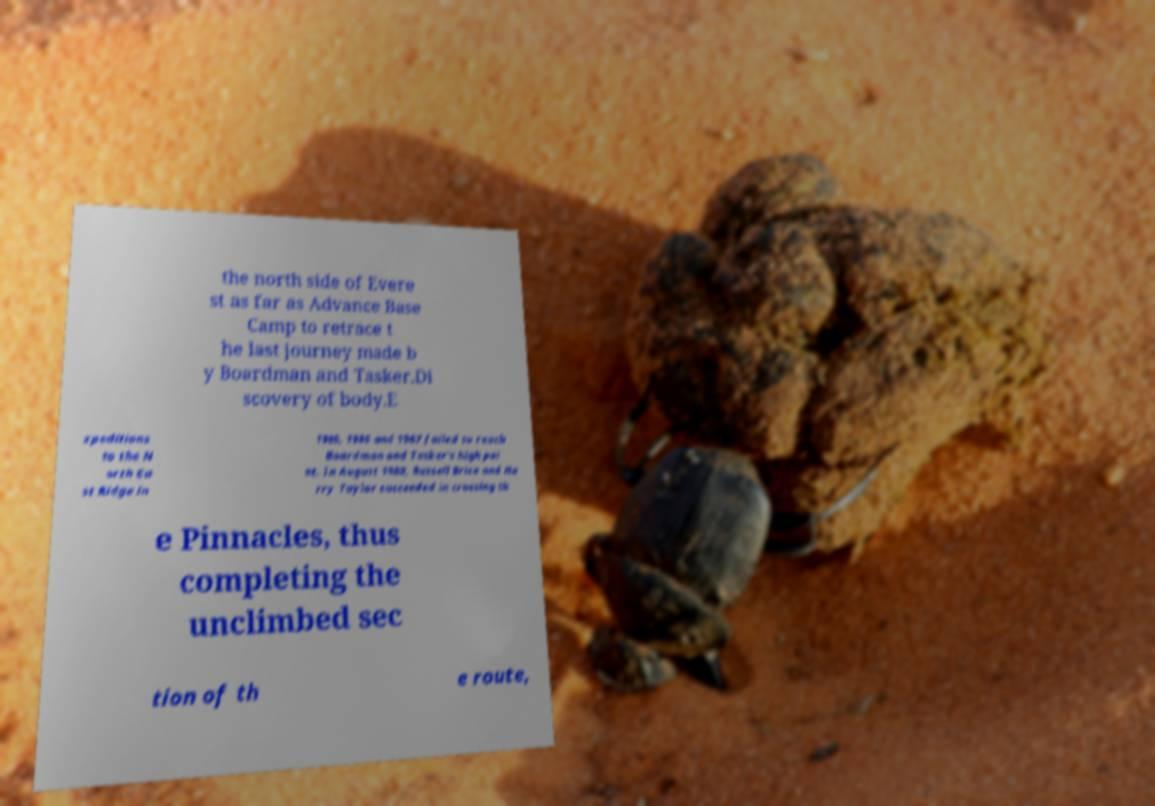What messages or text are displayed in this image? I need them in a readable, typed format. the north side of Evere st as far as Advance Base Camp to retrace t he last journey made b y Boardman and Tasker.Di scovery of body.E xpeditions to the N orth Ea st Ridge in 1985, 1986 and 1987 failed to reach Boardman and Tasker's high poi nt. In August 1988, Russell Brice and Ha rry Taylor succeeded in crossing th e Pinnacles, thus completing the unclimbed sec tion of th e route, 